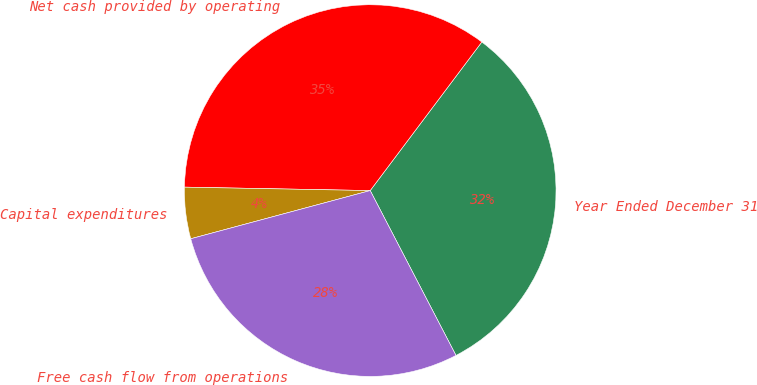<chart> <loc_0><loc_0><loc_500><loc_500><pie_chart><fcel>Year Ended December 31<fcel>Net cash provided by operating<fcel>Capital expenditures<fcel>Free cash flow from operations<nl><fcel>32.11%<fcel>34.96%<fcel>4.47%<fcel>28.46%<nl></chart> 